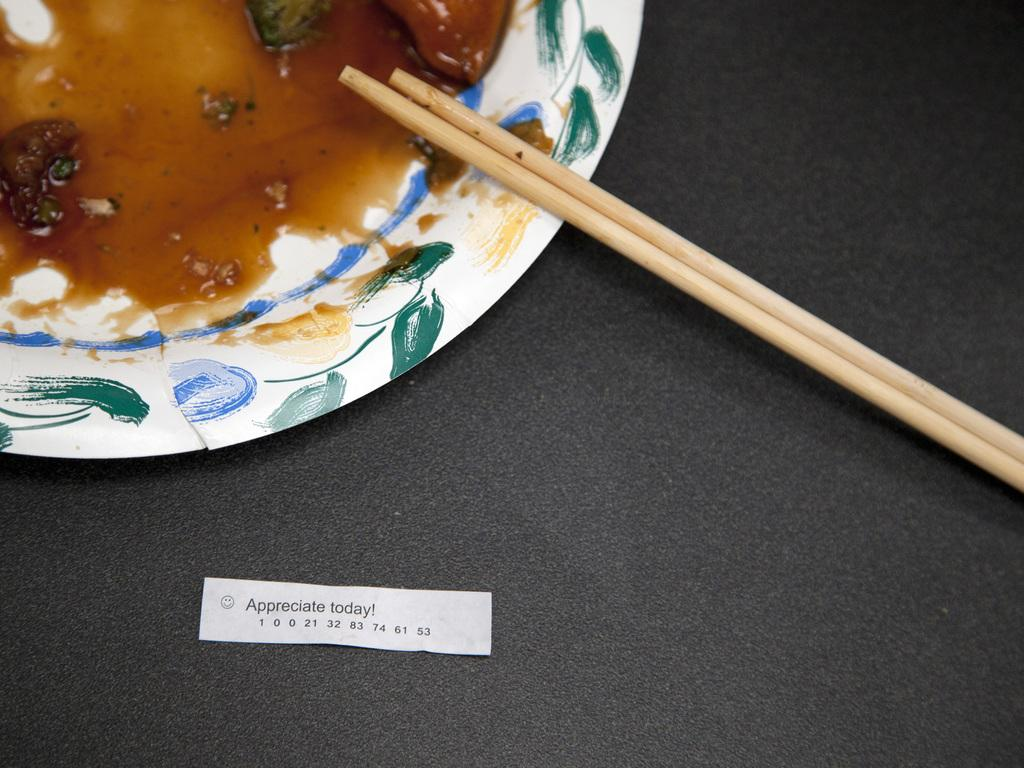What is on the plate in the image? There is a soap and vegetables on the plate. What utensils are present on the plate? There are two chopsticks on the plate. Is there any additional information visible in the image? Yes, there is a tag visible in the image. Where are the chickens playing in the image? There are no chickens or playground present in the image. 